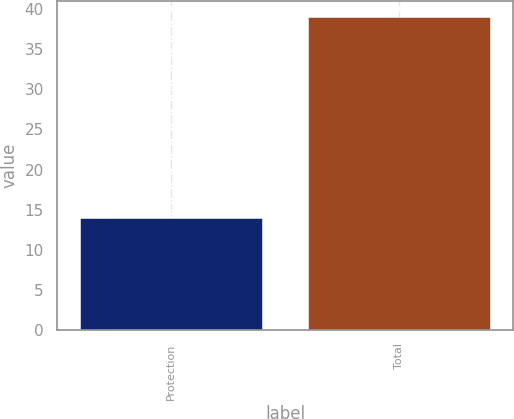Convert chart. <chart><loc_0><loc_0><loc_500><loc_500><bar_chart><fcel>Protection<fcel>Total<nl><fcel>14<fcel>39<nl></chart> 